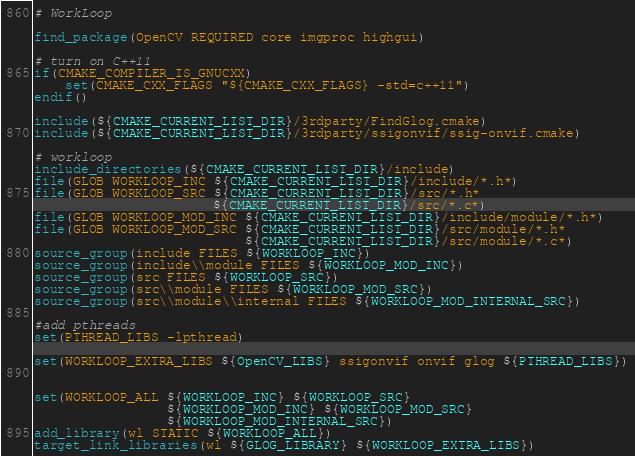Convert code to text. <code><loc_0><loc_0><loc_500><loc_500><_CMake_># WorkLoop

find_package(OpenCV REQUIRED core imgproc highgui)

# turn on C++11
if(CMAKE_COMPILER_IS_GNUCXX)
    set(CMAKE_CXX_FLAGS "${CMAKE_CXX_FLAGS} -std=c++11")
endif()

include(${CMAKE_CURRENT_LIST_DIR}/3rdparty/FindGlog.cmake)
include(${CMAKE_CURRENT_LIST_DIR}/3rdparty/ssigonvif/ssig-onvif.cmake)

# workloop
include_directories(${CMAKE_CURRENT_LIST_DIR}/include)
file(GLOB WORKLOOP_INC ${CMAKE_CURRENT_LIST_DIR}/include/*.h*)
file(GLOB WORKLOOP_SRC ${CMAKE_CURRENT_LIST_DIR}/src/*.h*
                       ${CMAKE_CURRENT_LIST_DIR}/src/*.c*)
file(GLOB WORKLOOP_MOD_INC ${CMAKE_CURRENT_LIST_DIR}/include/module/*.h*)
file(GLOB WORKLOOP_MOD_SRC ${CMAKE_CURRENT_LIST_DIR}/src/module/*.h*
                           ${CMAKE_CURRENT_LIST_DIR}/src/module/*.c*)
source_group(include FILES ${WORKLOOP_INC})
source_group(include\\module FILES ${WORKLOOP_MOD_INC})
source_group(src FILES ${WORKLOOP_SRC})
source_group(src\\module FILES ${WORKLOOP_MOD_SRC})
source_group(src\\module\\internal FILES ${WORKLOOP_MOD_INTERNAL_SRC})

#add pthreads
set(PTHREAD_LIBS -lpthread)

set(WORKLOOP_EXTRA_LIBS ${OpenCV_LIBS} ssigonvif onvif glog ${PTHREAD_LIBS})


set(WORKLOOP_ALL ${WORKLOOP_INC} ${WORKLOOP_SRC}
                 ${WORKLOOP_MOD_INC} ${WORKLOOP_MOD_SRC}
                 ${WORKLOOP_MOD_INTERNAL_SRC})
add_library(wl STATIC ${WORKLOOP_ALL})
target_link_libraries(wl ${GLOG_LIBRARY} ${WORKLOOP_EXTRA_LIBS})
</code> 